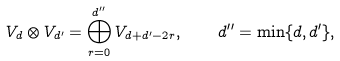Convert formula to latex. <formula><loc_0><loc_0><loc_500><loc_500>V _ { d } \otimes V _ { d ^ { \prime } } = \bigoplus _ { r = 0 } ^ { d ^ { \prime \prime } } V _ { d + d ^ { \prime } - 2 r } , \quad d ^ { \prime \prime } = { \min } \{ d , d ^ { \prime } \} ,</formula> 